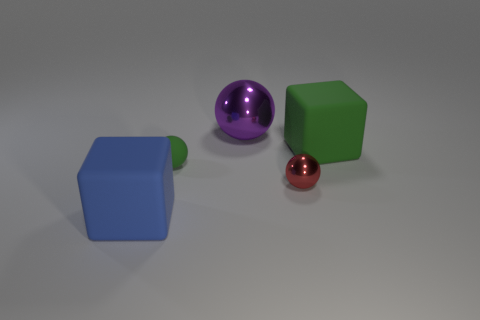Subtract all small red metal balls. How many balls are left? 2 Subtract 1 cubes. How many cubes are left? 1 Add 5 yellow metal cylinders. How many objects exist? 10 Subtract all purple spheres. How many spheres are left? 2 Subtract all purple balls. How many purple cubes are left? 0 Subtract all large yellow matte objects. Subtract all metal balls. How many objects are left? 3 Add 5 red metal things. How many red metal things are left? 6 Add 4 purple objects. How many purple objects exist? 5 Subtract 0 purple cylinders. How many objects are left? 5 Subtract all balls. How many objects are left? 2 